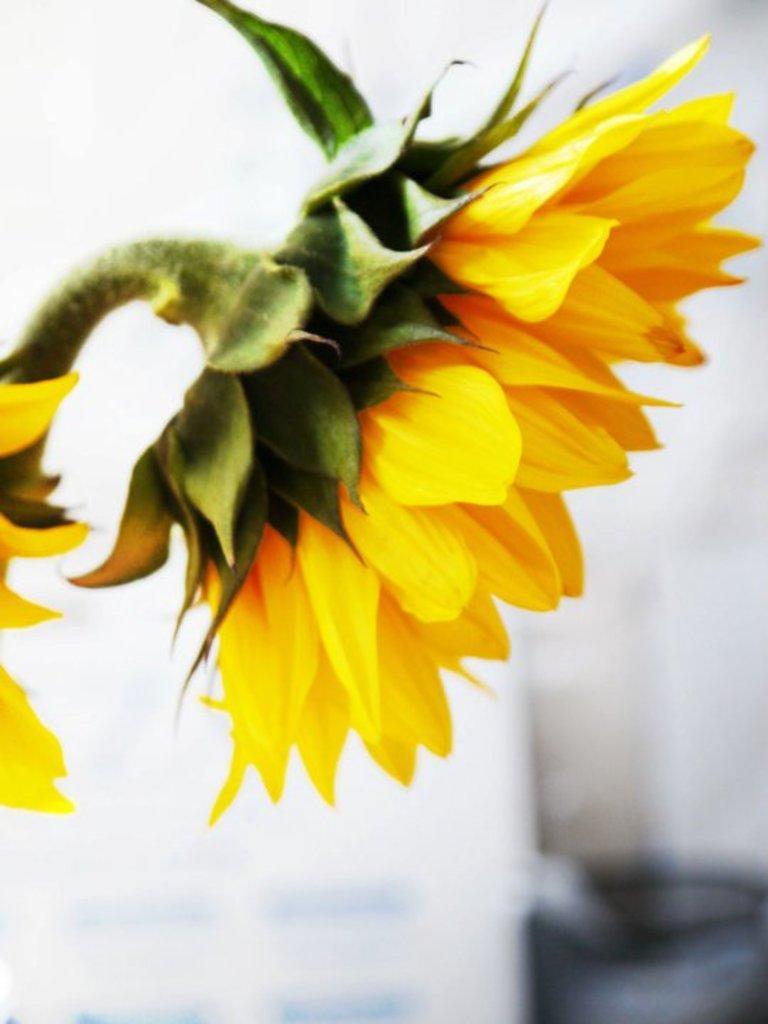How would you summarize this image in a sentence or two? In this image we can see two flowers. There are few objects behind the flower. 